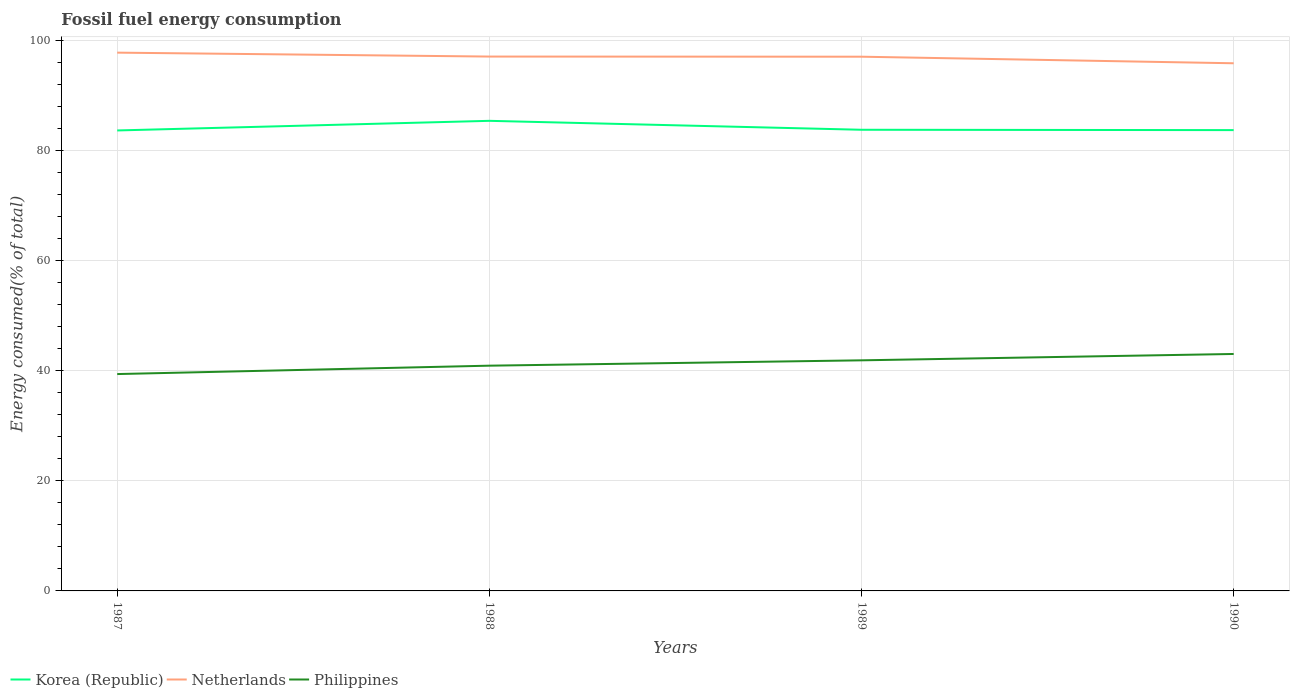How many different coloured lines are there?
Provide a short and direct response. 3. Does the line corresponding to Netherlands intersect with the line corresponding to Korea (Republic)?
Provide a succinct answer. No. Is the number of lines equal to the number of legend labels?
Ensure brevity in your answer.  Yes. Across all years, what is the maximum percentage of energy consumed in Korea (Republic)?
Provide a succinct answer. 83.72. What is the total percentage of energy consumed in Korea (Republic) in the graph?
Your answer should be very brief. -0.12. What is the difference between the highest and the second highest percentage of energy consumed in Korea (Republic)?
Provide a succinct answer. 1.75. Is the percentage of energy consumed in Philippines strictly greater than the percentage of energy consumed in Korea (Republic) over the years?
Your response must be concise. Yes. How many lines are there?
Keep it short and to the point. 3. Does the graph contain any zero values?
Ensure brevity in your answer.  No. Does the graph contain grids?
Provide a succinct answer. Yes. Where does the legend appear in the graph?
Offer a terse response. Bottom left. How are the legend labels stacked?
Provide a succinct answer. Horizontal. What is the title of the graph?
Offer a very short reply. Fossil fuel energy consumption. What is the label or title of the X-axis?
Ensure brevity in your answer.  Years. What is the label or title of the Y-axis?
Keep it short and to the point. Energy consumed(% of total). What is the Energy consumed(% of total) of Korea (Republic) in 1987?
Your answer should be compact. 83.72. What is the Energy consumed(% of total) in Netherlands in 1987?
Your answer should be compact. 97.86. What is the Energy consumed(% of total) in Philippines in 1987?
Offer a terse response. 39.43. What is the Energy consumed(% of total) of Korea (Republic) in 1988?
Your answer should be very brief. 85.47. What is the Energy consumed(% of total) of Netherlands in 1988?
Give a very brief answer. 97.15. What is the Energy consumed(% of total) of Philippines in 1988?
Keep it short and to the point. 40.95. What is the Energy consumed(% of total) of Korea (Republic) in 1989?
Give a very brief answer. 83.84. What is the Energy consumed(% of total) in Netherlands in 1989?
Keep it short and to the point. 97.13. What is the Energy consumed(% of total) in Philippines in 1989?
Your response must be concise. 41.92. What is the Energy consumed(% of total) in Korea (Republic) in 1990?
Ensure brevity in your answer.  83.78. What is the Energy consumed(% of total) in Netherlands in 1990?
Provide a short and direct response. 95.93. What is the Energy consumed(% of total) in Philippines in 1990?
Your answer should be very brief. 43.08. Across all years, what is the maximum Energy consumed(% of total) of Korea (Republic)?
Your answer should be compact. 85.47. Across all years, what is the maximum Energy consumed(% of total) in Netherlands?
Provide a short and direct response. 97.86. Across all years, what is the maximum Energy consumed(% of total) of Philippines?
Make the answer very short. 43.08. Across all years, what is the minimum Energy consumed(% of total) of Korea (Republic)?
Offer a terse response. 83.72. Across all years, what is the minimum Energy consumed(% of total) in Netherlands?
Offer a very short reply. 95.93. Across all years, what is the minimum Energy consumed(% of total) of Philippines?
Offer a very short reply. 39.43. What is the total Energy consumed(% of total) in Korea (Republic) in the graph?
Ensure brevity in your answer.  336.81. What is the total Energy consumed(% of total) in Netherlands in the graph?
Make the answer very short. 388.07. What is the total Energy consumed(% of total) of Philippines in the graph?
Give a very brief answer. 165.38. What is the difference between the Energy consumed(% of total) of Korea (Republic) in 1987 and that in 1988?
Provide a succinct answer. -1.75. What is the difference between the Energy consumed(% of total) of Netherlands in 1987 and that in 1988?
Offer a very short reply. 0.71. What is the difference between the Energy consumed(% of total) of Philippines in 1987 and that in 1988?
Give a very brief answer. -1.52. What is the difference between the Energy consumed(% of total) in Korea (Republic) in 1987 and that in 1989?
Ensure brevity in your answer.  -0.12. What is the difference between the Energy consumed(% of total) of Netherlands in 1987 and that in 1989?
Your answer should be very brief. 0.74. What is the difference between the Energy consumed(% of total) in Philippines in 1987 and that in 1989?
Your answer should be very brief. -2.5. What is the difference between the Energy consumed(% of total) in Korea (Republic) in 1987 and that in 1990?
Provide a succinct answer. -0.06. What is the difference between the Energy consumed(% of total) in Netherlands in 1987 and that in 1990?
Ensure brevity in your answer.  1.93. What is the difference between the Energy consumed(% of total) of Philippines in 1987 and that in 1990?
Your answer should be compact. -3.65. What is the difference between the Energy consumed(% of total) in Korea (Republic) in 1988 and that in 1989?
Offer a terse response. 1.62. What is the difference between the Energy consumed(% of total) of Netherlands in 1988 and that in 1989?
Offer a very short reply. 0.03. What is the difference between the Energy consumed(% of total) of Philippines in 1988 and that in 1989?
Ensure brevity in your answer.  -0.97. What is the difference between the Energy consumed(% of total) in Korea (Republic) in 1988 and that in 1990?
Give a very brief answer. 1.69. What is the difference between the Energy consumed(% of total) of Netherlands in 1988 and that in 1990?
Ensure brevity in your answer.  1.22. What is the difference between the Energy consumed(% of total) of Philippines in 1988 and that in 1990?
Keep it short and to the point. -2.13. What is the difference between the Energy consumed(% of total) of Korea (Republic) in 1989 and that in 1990?
Your answer should be very brief. 0.06. What is the difference between the Energy consumed(% of total) of Netherlands in 1989 and that in 1990?
Your response must be concise. 1.19. What is the difference between the Energy consumed(% of total) in Philippines in 1989 and that in 1990?
Offer a terse response. -1.16. What is the difference between the Energy consumed(% of total) in Korea (Republic) in 1987 and the Energy consumed(% of total) in Netherlands in 1988?
Your answer should be compact. -13.43. What is the difference between the Energy consumed(% of total) of Korea (Republic) in 1987 and the Energy consumed(% of total) of Philippines in 1988?
Your answer should be compact. 42.77. What is the difference between the Energy consumed(% of total) of Netherlands in 1987 and the Energy consumed(% of total) of Philippines in 1988?
Offer a very short reply. 56.91. What is the difference between the Energy consumed(% of total) in Korea (Republic) in 1987 and the Energy consumed(% of total) in Netherlands in 1989?
Give a very brief answer. -13.41. What is the difference between the Energy consumed(% of total) in Korea (Republic) in 1987 and the Energy consumed(% of total) in Philippines in 1989?
Offer a terse response. 41.79. What is the difference between the Energy consumed(% of total) in Netherlands in 1987 and the Energy consumed(% of total) in Philippines in 1989?
Keep it short and to the point. 55.94. What is the difference between the Energy consumed(% of total) in Korea (Republic) in 1987 and the Energy consumed(% of total) in Netherlands in 1990?
Make the answer very short. -12.21. What is the difference between the Energy consumed(% of total) in Korea (Republic) in 1987 and the Energy consumed(% of total) in Philippines in 1990?
Provide a succinct answer. 40.64. What is the difference between the Energy consumed(% of total) in Netherlands in 1987 and the Energy consumed(% of total) in Philippines in 1990?
Your response must be concise. 54.78. What is the difference between the Energy consumed(% of total) in Korea (Republic) in 1988 and the Energy consumed(% of total) in Netherlands in 1989?
Ensure brevity in your answer.  -11.66. What is the difference between the Energy consumed(% of total) in Korea (Republic) in 1988 and the Energy consumed(% of total) in Philippines in 1989?
Your response must be concise. 43.54. What is the difference between the Energy consumed(% of total) in Netherlands in 1988 and the Energy consumed(% of total) in Philippines in 1989?
Provide a succinct answer. 55.23. What is the difference between the Energy consumed(% of total) in Korea (Republic) in 1988 and the Energy consumed(% of total) in Netherlands in 1990?
Keep it short and to the point. -10.47. What is the difference between the Energy consumed(% of total) of Korea (Republic) in 1988 and the Energy consumed(% of total) of Philippines in 1990?
Give a very brief answer. 42.39. What is the difference between the Energy consumed(% of total) in Netherlands in 1988 and the Energy consumed(% of total) in Philippines in 1990?
Offer a very short reply. 54.07. What is the difference between the Energy consumed(% of total) in Korea (Republic) in 1989 and the Energy consumed(% of total) in Netherlands in 1990?
Provide a succinct answer. -12.09. What is the difference between the Energy consumed(% of total) in Korea (Republic) in 1989 and the Energy consumed(% of total) in Philippines in 1990?
Give a very brief answer. 40.76. What is the difference between the Energy consumed(% of total) in Netherlands in 1989 and the Energy consumed(% of total) in Philippines in 1990?
Provide a succinct answer. 54.05. What is the average Energy consumed(% of total) of Korea (Republic) per year?
Offer a very short reply. 84.2. What is the average Energy consumed(% of total) in Netherlands per year?
Offer a terse response. 97.02. What is the average Energy consumed(% of total) of Philippines per year?
Make the answer very short. 41.35. In the year 1987, what is the difference between the Energy consumed(% of total) in Korea (Republic) and Energy consumed(% of total) in Netherlands?
Your answer should be very brief. -14.14. In the year 1987, what is the difference between the Energy consumed(% of total) in Korea (Republic) and Energy consumed(% of total) in Philippines?
Make the answer very short. 44.29. In the year 1987, what is the difference between the Energy consumed(% of total) of Netherlands and Energy consumed(% of total) of Philippines?
Give a very brief answer. 58.44. In the year 1988, what is the difference between the Energy consumed(% of total) of Korea (Republic) and Energy consumed(% of total) of Netherlands?
Provide a short and direct response. -11.68. In the year 1988, what is the difference between the Energy consumed(% of total) in Korea (Republic) and Energy consumed(% of total) in Philippines?
Ensure brevity in your answer.  44.51. In the year 1988, what is the difference between the Energy consumed(% of total) in Netherlands and Energy consumed(% of total) in Philippines?
Offer a terse response. 56.2. In the year 1989, what is the difference between the Energy consumed(% of total) of Korea (Republic) and Energy consumed(% of total) of Netherlands?
Provide a succinct answer. -13.28. In the year 1989, what is the difference between the Energy consumed(% of total) in Korea (Republic) and Energy consumed(% of total) in Philippines?
Provide a short and direct response. 41.92. In the year 1989, what is the difference between the Energy consumed(% of total) in Netherlands and Energy consumed(% of total) in Philippines?
Your answer should be compact. 55.2. In the year 1990, what is the difference between the Energy consumed(% of total) of Korea (Republic) and Energy consumed(% of total) of Netherlands?
Your response must be concise. -12.15. In the year 1990, what is the difference between the Energy consumed(% of total) of Korea (Republic) and Energy consumed(% of total) of Philippines?
Provide a succinct answer. 40.7. In the year 1990, what is the difference between the Energy consumed(% of total) of Netherlands and Energy consumed(% of total) of Philippines?
Give a very brief answer. 52.85. What is the ratio of the Energy consumed(% of total) in Korea (Republic) in 1987 to that in 1988?
Your response must be concise. 0.98. What is the ratio of the Energy consumed(% of total) of Netherlands in 1987 to that in 1988?
Offer a terse response. 1.01. What is the ratio of the Energy consumed(% of total) of Philippines in 1987 to that in 1988?
Your response must be concise. 0.96. What is the ratio of the Energy consumed(% of total) in Netherlands in 1987 to that in 1989?
Your answer should be compact. 1.01. What is the ratio of the Energy consumed(% of total) of Philippines in 1987 to that in 1989?
Ensure brevity in your answer.  0.94. What is the ratio of the Energy consumed(% of total) in Korea (Republic) in 1987 to that in 1990?
Provide a short and direct response. 1. What is the ratio of the Energy consumed(% of total) in Netherlands in 1987 to that in 1990?
Offer a very short reply. 1.02. What is the ratio of the Energy consumed(% of total) of Philippines in 1987 to that in 1990?
Provide a succinct answer. 0.92. What is the ratio of the Energy consumed(% of total) of Korea (Republic) in 1988 to that in 1989?
Give a very brief answer. 1.02. What is the ratio of the Energy consumed(% of total) of Philippines in 1988 to that in 1989?
Offer a terse response. 0.98. What is the ratio of the Energy consumed(% of total) in Korea (Republic) in 1988 to that in 1990?
Your answer should be compact. 1.02. What is the ratio of the Energy consumed(% of total) of Netherlands in 1988 to that in 1990?
Ensure brevity in your answer.  1.01. What is the ratio of the Energy consumed(% of total) of Philippines in 1988 to that in 1990?
Ensure brevity in your answer.  0.95. What is the ratio of the Energy consumed(% of total) in Netherlands in 1989 to that in 1990?
Ensure brevity in your answer.  1.01. What is the ratio of the Energy consumed(% of total) of Philippines in 1989 to that in 1990?
Ensure brevity in your answer.  0.97. What is the difference between the highest and the second highest Energy consumed(% of total) in Korea (Republic)?
Provide a short and direct response. 1.62. What is the difference between the highest and the second highest Energy consumed(% of total) in Netherlands?
Ensure brevity in your answer.  0.71. What is the difference between the highest and the second highest Energy consumed(% of total) of Philippines?
Give a very brief answer. 1.16. What is the difference between the highest and the lowest Energy consumed(% of total) of Korea (Republic)?
Make the answer very short. 1.75. What is the difference between the highest and the lowest Energy consumed(% of total) in Netherlands?
Ensure brevity in your answer.  1.93. What is the difference between the highest and the lowest Energy consumed(% of total) of Philippines?
Keep it short and to the point. 3.65. 